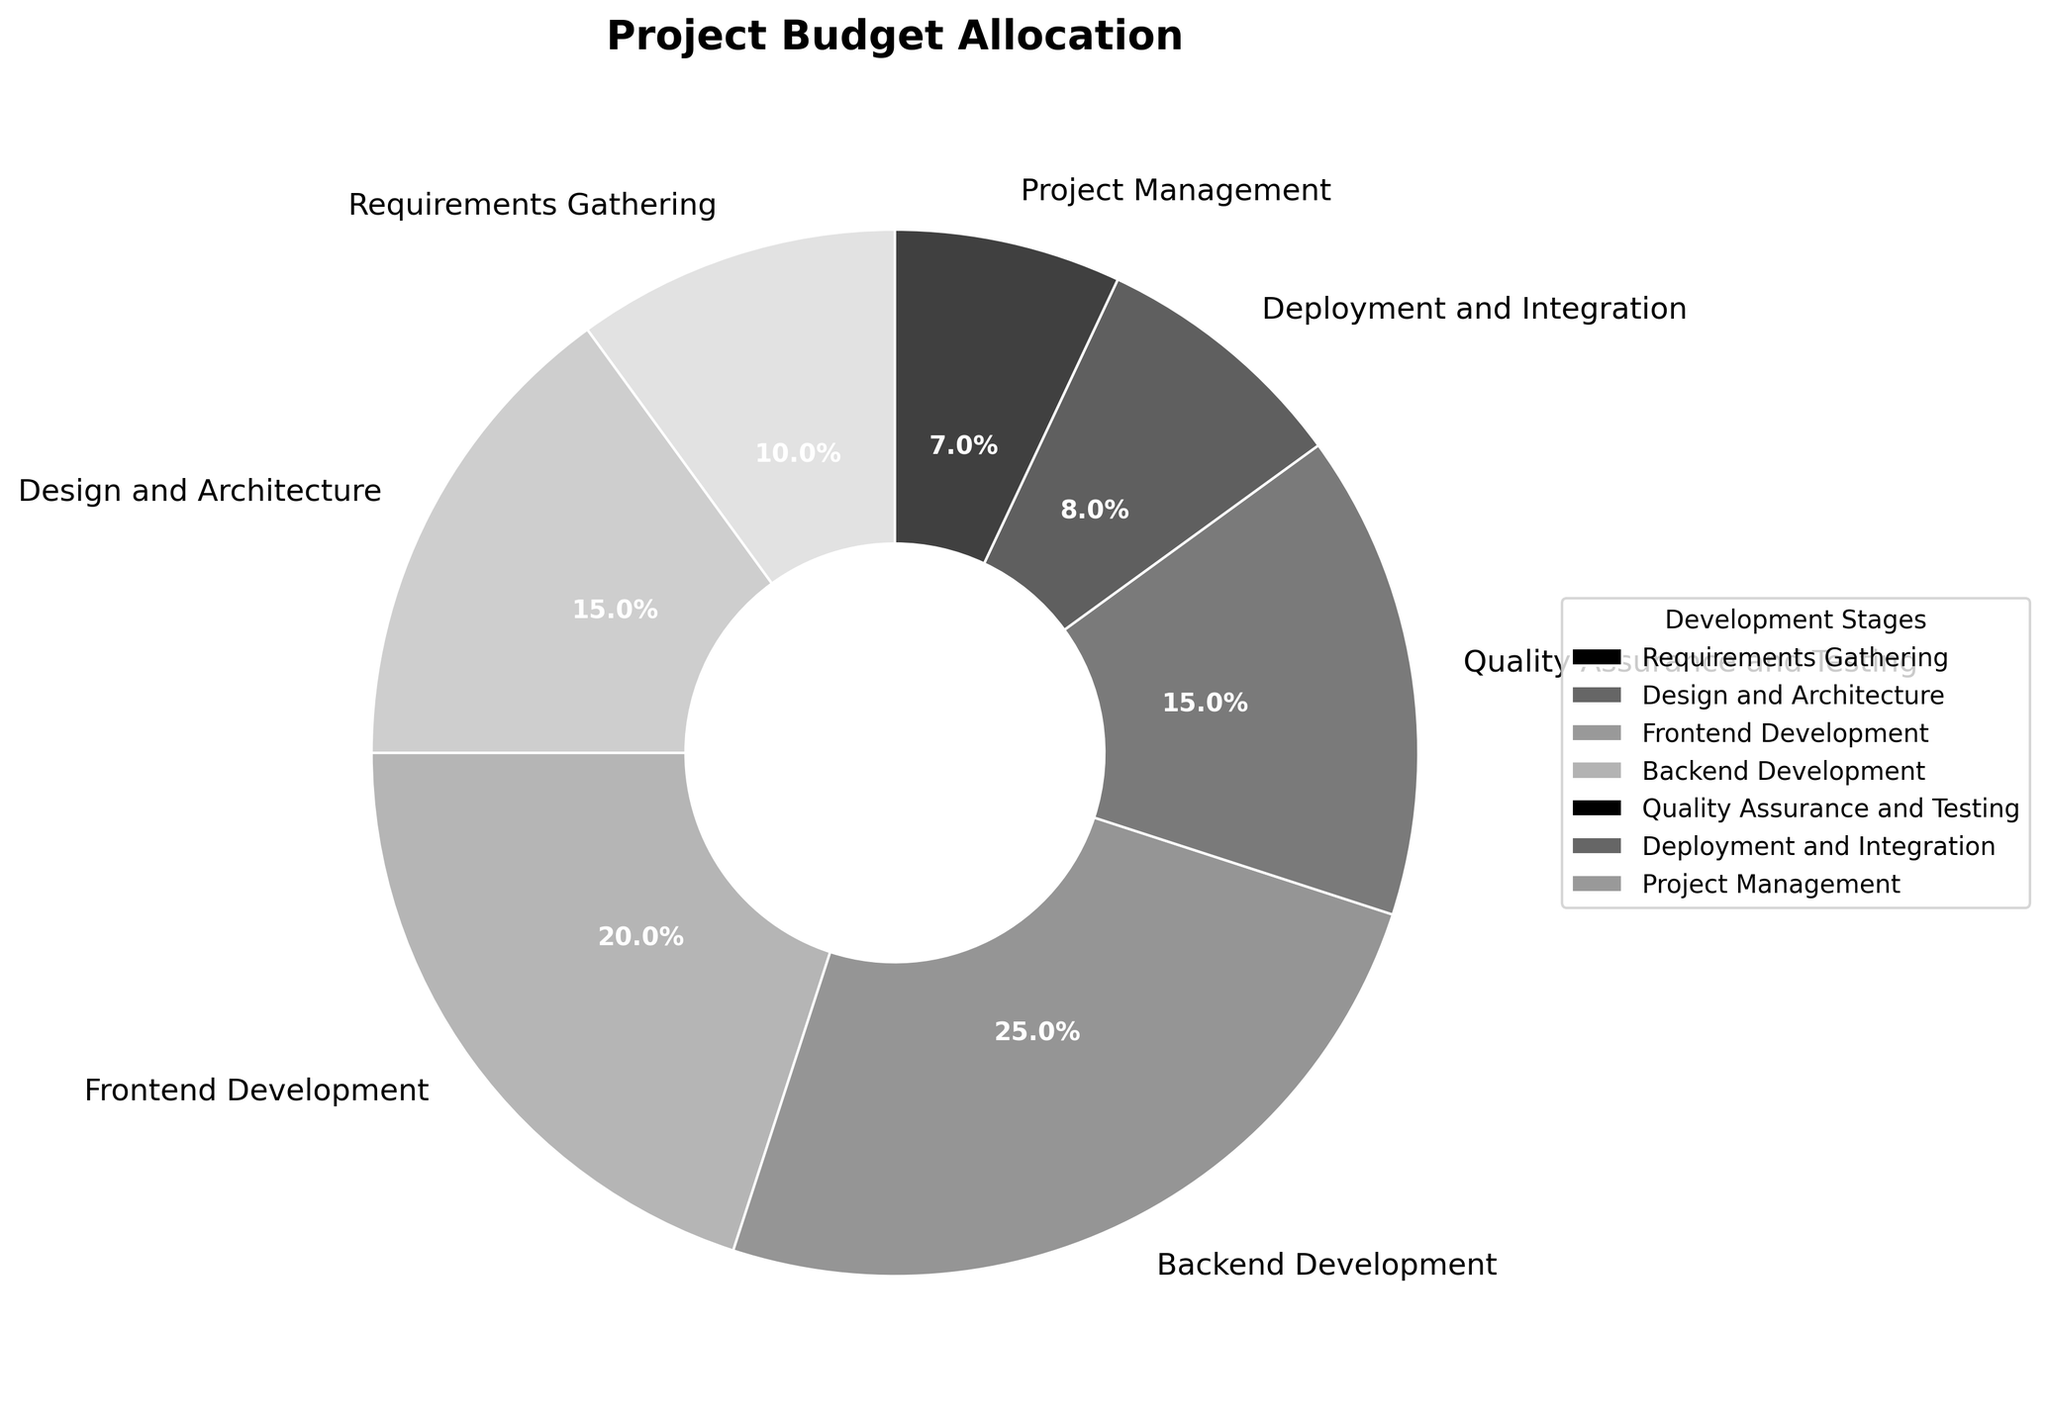Which development stage has the highest budget allocation? The pie chart shows that Backend Development has the largest wedge, representing the highest budget allocation.
Answer: Backend Development What is the combined budget allocation for Design and Architecture and Quality Assurance and Testing? Design and Architecture has a budget allocation of 15%, and Quality Assurance and Testing has 15%. Adding them together gives 15% + 15% = 30%.
Answer: 30% Which stage has the least amount of the budget allocation? The pie chart indicates that Project Management has the smallest wedge, representing the least budget allocation.
Answer: Project Management How does the budget allocation for Frontend Development compare to Deployment and Integration? Frontend Development has a budget allocation of 20%, whereas Deployment and Integration has 8%. Thus, the budget for Frontend Development is greater.
Answer: Frontend Development is greater What percentage of the budget is allocated between Requirements Gathering and Project Management? Requirements Gathering has a budget allocation of 10%, and Project Management has 7%. Adding them together gives 10% + 7% = 17%.
Answer: 17% Is the budget allocated to Quality Assurance and Testing more than the budget allocated to Deployment and Integration? From the pie chart, Quality Assurance and Testing has a budget allocation of 15%, and Deployment and Integration has 8%. Since 15% > 8%, the budget for Quality Assurance and Testing is more.
Answer: Yes Which development stage has a budget allocation twice as much as Deployment and Integration? Deployment and Integration has a budget allocation of 8%. The stage with a budget close to 16% (twice 8%) is Design and Architecture, which has 15%, close to twice of Deployment and Integration.
Answer: Design and Architecture What is the total budget allocation for all stages related to coding (Frontend and Backend Development)? Frontend Development has a budget allocation of 20%, and Backend Development has 25%. Adding them together gives 20% + 25% = 45%.
Answer: 45% How much more budget is allocated to Backend Development compared to Project Management? Backend Development has a budget allocation of 25%, and Project Management has 7%. Subtracting these gives 25% - 7% = 18%.
Answer: 18% Which development stages have equal budget allocations? Both Design and Architecture and Quality Assurance and Testing have a budget allocation of 15%.
Answer: Design and Architecture and Quality Assurance and Testing 